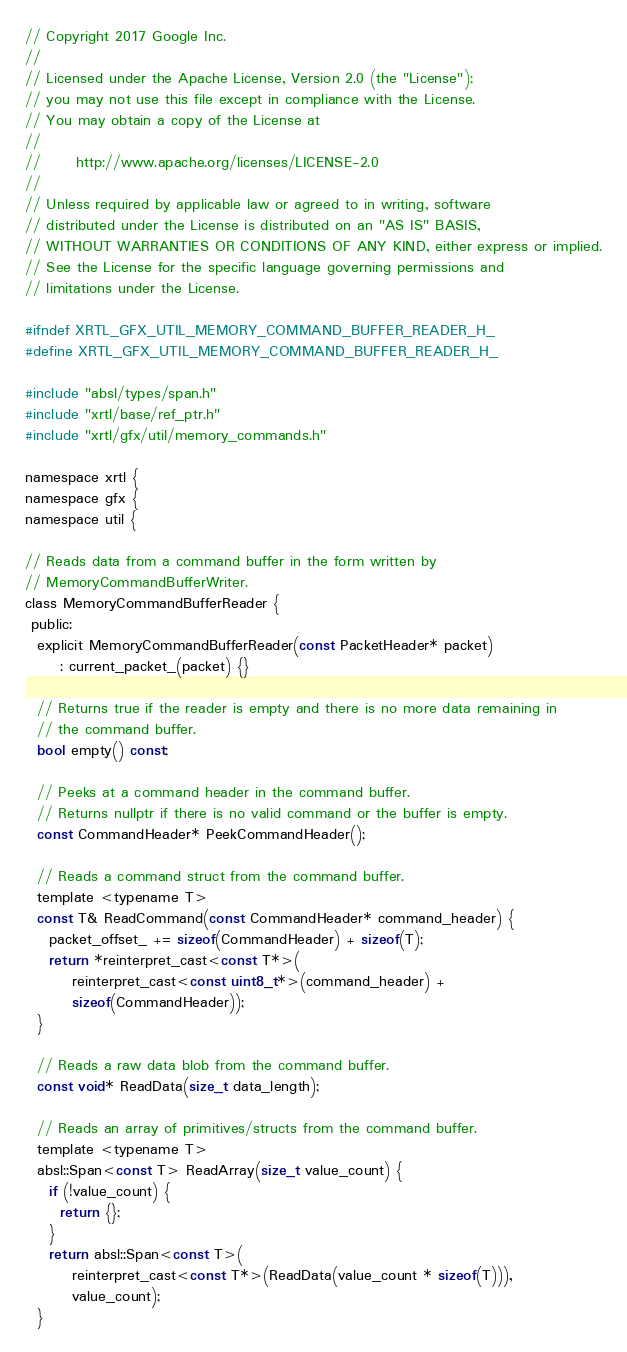<code> <loc_0><loc_0><loc_500><loc_500><_C_>// Copyright 2017 Google Inc.
//
// Licensed under the Apache License, Version 2.0 (the "License");
// you may not use this file except in compliance with the License.
// You may obtain a copy of the License at
//
//      http://www.apache.org/licenses/LICENSE-2.0
//
// Unless required by applicable law or agreed to in writing, software
// distributed under the License is distributed on an "AS IS" BASIS,
// WITHOUT WARRANTIES OR CONDITIONS OF ANY KIND, either express or implied.
// See the License for the specific language governing permissions and
// limitations under the License.

#ifndef XRTL_GFX_UTIL_MEMORY_COMMAND_BUFFER_READER_H_
#define XRTL_GFX_UTIL_MEMORY_COMMAND_BUFFER_READER_H_

#include "absl/types/span.h"
#include "xrtl/base/ref_ptr.h"
#include "xrtl/gfx/util/memory_commands.h"

namespace xrtl {
namespace gfx {
namespace util {

// Reads data from a command buffer in the form written by
// MemoryCommandBufferWriter.
class MemoryCommandBufferReader {
 public:
  explicit MemoryCommandBufferReader(const PacketHeader* packet)
      : current_packet_(packet) {}

  // Returns true if the reader is empty and there is no more data remaining in
  // the command buffer.
  bool empty() const;

  // Peeks at a command header in the command buffer.
  // Returns nullptr if there is no valid command or the buffer is empty.
  const CommandHeader* PeekCommandHeader();

  // Reads a command struct from the command buffer.
  template <typename T>
  const T& ReadCommand(const CommandHeader* command_header) {
    packet_offset_ += sizeof(CommandHeader) + sizeof(T);
    return *reinterpret_cast<const T*>(
        reinterpret_cast<const uint8_t*>(command_header) +
        sizeof(CommandHeader));
  }

  // Reads a raw data blob from the command buffer.
  const void* ReadData(size_t data_length);

  // Reads an array of primitives/structs from the command buffer.
  template <typename T>
  absl::Span<const T> ReadArray(size_t value_count) {
    if (!value_count) {
      return {};
    }
    return absl::Span<const T>(
        reinterpret_cast<const T*>(ReadData(value_count * sizeof(T))),
        value_count);
  }
</code> 